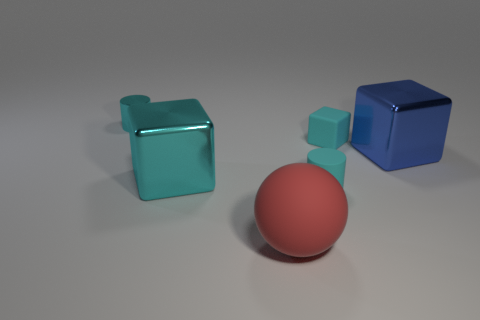What material is the tiny cyan thing that is both behind the large cyan metallic thing and to the right of the large red ball?
Provide a short and direct response. Rubber. Does the small rubber cylinder have the same color as the big cube that is left of the red object?
Offer a terse response. Yes. The other cyan matte thing that is the same shape as the big cyan object is what size?
Offer a very short reply. Small. What is the shape of the metallic thing that is in front of the tiny cyan matte cube and on the left side of the big red matte sphere?
Ensure brevity in your answer.  Cube. Do the cyan metallic cylinder and the cyan cube on the right side of the cyan metallic block have the same size?
Offer a terse response. Yes. The tiny rubber thing that is the same shape as the small metal thing is what color?
Your answer should be very brief. Cyan. Is the blue shiny object the same shape as the big cyan metallic thing?
Ensure brevity in your answer.  Yes. What shape is the big metallic thing that is the same color as the metallic cylinder?
Your answer should be compact. Cube. What is the size of the cyan block that is made of the same material as the large red ball?
Keep it short and to the point. Small. Is there any other thing that is the same color as the small shiny thing?
Give a very brief answer. Yes. 